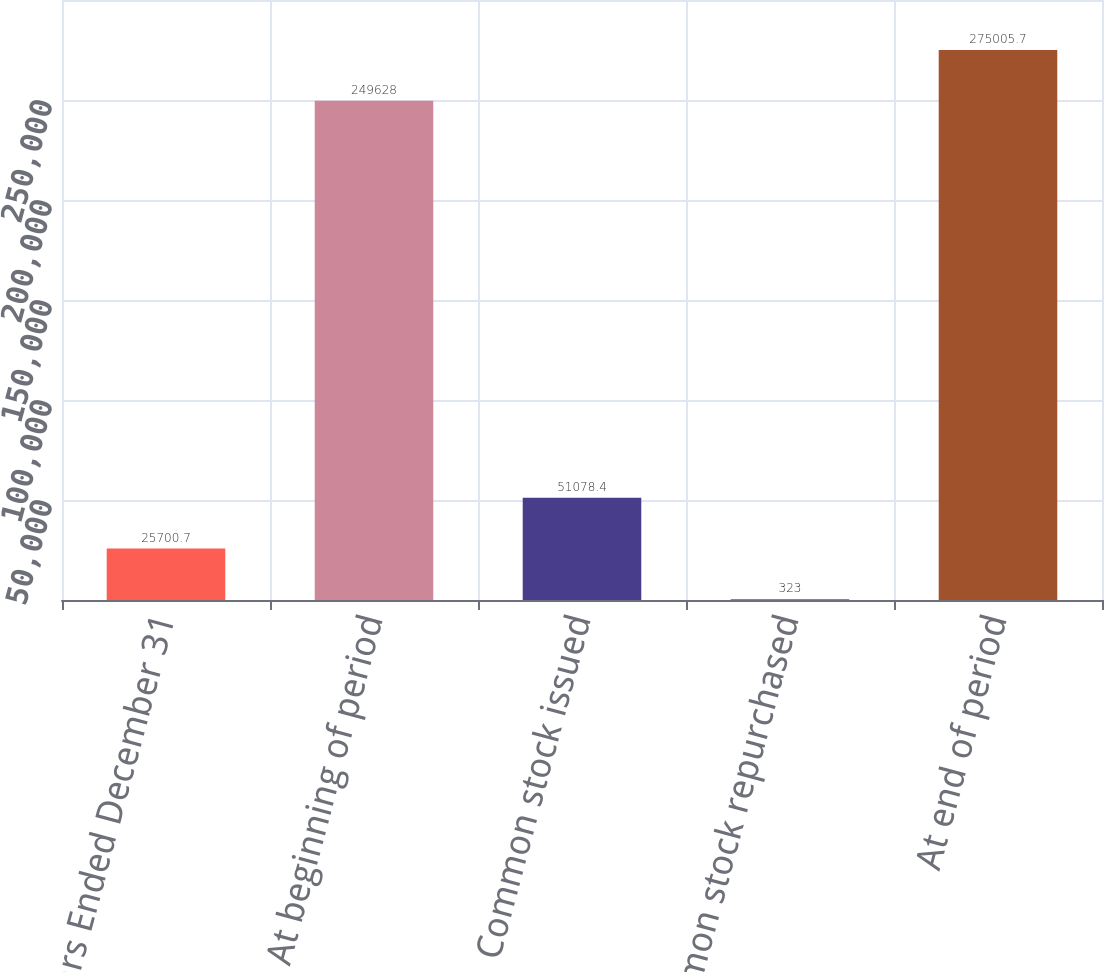Convert chart. <chart><loc_0><loc_0><loc_500><loc_500><bar_chart><fcel>Years Ended December 31<fcel>At beginning of period<fcel>Common stock issued<fcel>Common stock repurchased<fcel>At end of period<nl><fcel>25700.7<fcel>249628<fcel>51078.4<fcel>323<fcel>275006<nl></chart> 